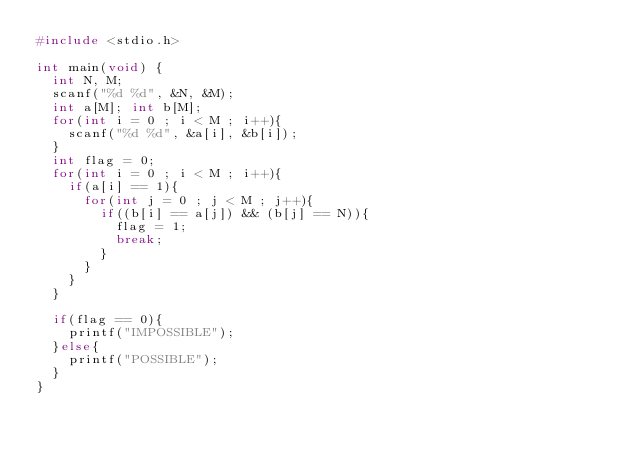<code> <loc_0><loc_0><loc_500><loc_500><_C_>#include <stdio.h>

int main(void) {
	int N, M;
	scanf("%d %d", &N, &M);
	int a[M]; int b[M];
	for(int i = 0 ; i < M ; i++){
		scanf("%d %d", &a[i], &b[i]);
	}
	int flag = 0;
	for(int i = 0 ; i < M ; i++){
		if(a[i] == 1){
			for(int j = 0 ; j < M ; j++){
				if((b[i] == a[j]) && (b[j] == N)){
					flag = 1;
					break;
				}
			}
		}
	}

	if(flag == 0){
		printf("IMPOSSIBLE");
	}else{
		printf("POSSIBLE");
	}
}</code> 